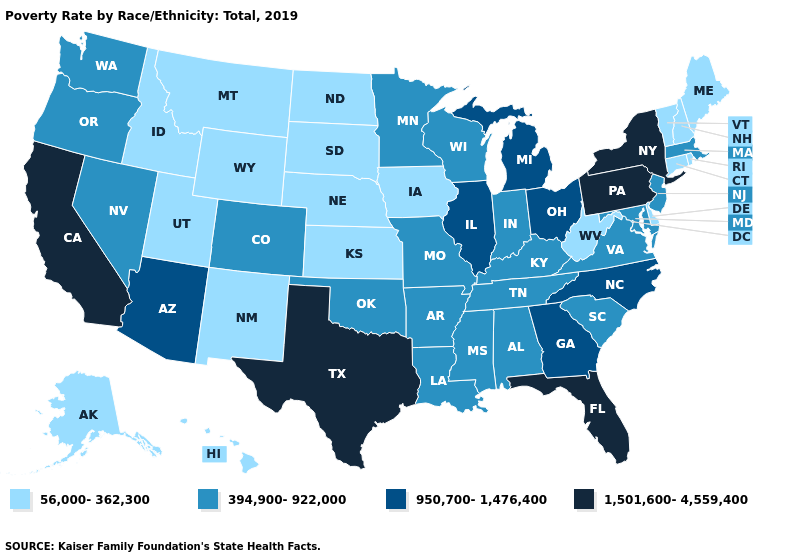Does Oregon have the lowest value in the USA?
Quick response, please. No. Name the states that have a value in the range 394,900-922,000?
Quick response, please. Alabama, Arkansas, Colorado, Indiana, Kentucky, Louisiana, Maryland, Massachusetts, Minnesota, Mississippi, Missouri, Nevada, New Jersey, Oklahoma, Oregon, South Carolina, Tennessee, Virginia, Washington, Wisconsin. Among the states that border Alabama , does Florida have the highest value?
Short answer required. Yes. Does Alabama have the lowest value in the USA?
Answer briefly. No. Among the states that border Arkansas , which have the highest value?
Answer briefly. Texas. Which states have the lowest value in the MidWest?
Answer briefly. Iowa, Kansas, Nebraska, North Dakota, South Dakota. Does New Jersey have the lowest value in the Northeast?
Concise answer only. No. Name the states that have a value in the range 950,700-1,476,400?
Quick response, please. Arizona, Georgia, Illinois, Michigan, North Carolina, Ohio. Name the states that have a value in the range 56,000-362,300?
Short answer required. Alaska, Connecticut, Delaware, Hawaii, Idaho, Iowa, Kansas, Maine, Montana, Nebraska, New Hampshire, New Mexico, North Dakota, Rhode Island, South Dakota, Utah, Vermont, West Virginia, Wyoming. What is the highest value in the USA?
Answer briefly. 1,501,600-4,559,400. What is the lowest value in states that border New Hampshire?
Give a very brief answer. 56,000-362,300. Does Kentucky have the lowest value in the USA?
Short answer required. No. What is the highest value in the MidWest ?
Write a very short answer. 950,700-1,476,400. What is the lowest value in the MidWest?
Be succinct. 56,000-362,300. 